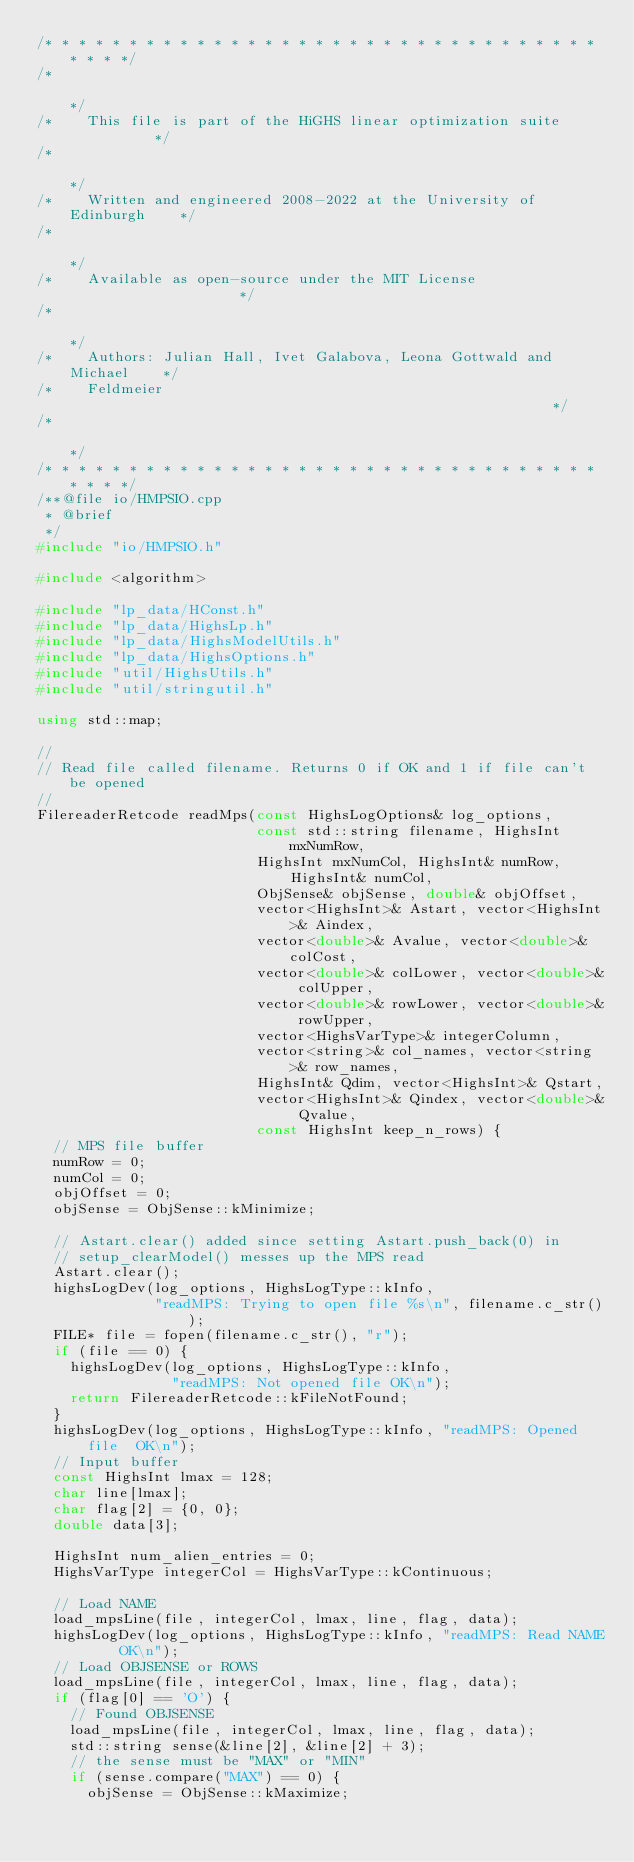<code> <loc_0><loc_0><loc_500><loc_500><_C++_>/* * * * * * * * * * * * * * * * * * * * * * * * * * * * * * * * * * * * */
/*                                                                       */
/*    This file is part of the HiGHS linear optimization suite           */
/*                                                                       */
/*    Written and engineered 2008-2022 at the University of Edinburgh    */
/*                                                                       */
/*    Available as open-source under the MIT License                     */
/*                                                                       */
/*    Authors: Julian Hall, Ivet Galabova, Leona Gottwald and Michael    */
/*    Feldmeier                                                          */
/*                                                                       */
/* * * * * * * * * * * * * * * * * * * * * * * * * * * * * * * * * * * * */
/**@file io/HMPSIO.cpp
 * @brief
 */
#include "io/HMPSIO.h"

#include <algorithm>

#include "lp_data/HConst.h"
#include "lp_data/HighsLp.h"
#include "lp_data/HighsModelUtils.h"
#include "lp_data/HighsOptions.h"
#include "util/HighsUtils.h"
#include "util/stringutil.h"

using std::map;

//
// Read file called filename. Returns 0 if OK and 1 if file can't be opened
//
FilereaderRetcode readMps(const HighsLogOptions& log_options,
                          const std::string filename, HighsInt mxNumRow,
                          HighsInt mxNumCol, HighsInt& numRow, HighsInt& numCol,
                          ObjSense& objSense, double& objOffset,
                          vector<HighsInt>& Astart, vector<HighsInt>& Aindex,
                          vector<double>& Avalue, vector<double>& colCost,
                          vector<double>& colLower, vector<double>& colUpper,
                          vector<double>& rowLower, vector<double>& rowUpper,
                          vector<HighsVarType>& integerColumn,
                          vector<string>& col_names, vector<string>& row_names,
                          HighsInt& Qdim, vector<HighsInt>& Qstart,
                          vector<HighsInt>& Qindex, vector<double>& Qvalue,
                          const HighsInt keep_n_rows) {
  // MPS file buffer
  numRow = 0;
  numCol = 0;
  objOffset = 0;
  objSense = ObjSense::kMinimize;

  // Astart.clear() added since setting Astart.push_back(0) in
  // setup_clearModel() messes up the MPS read
  Astart.clear();
  highsLogDev(log_options, HighsLogType::kInfo,
              "readMPS: Trying to open file %s\n", filename.c_str());
  FILE* file = fopen(filename.c_str(), "r");
  if (file == 0) {
    highsLogDev(log_options, HighsLogType::kInfo,
                "readMPS: Not opened file OK\n");
    return FilereaderRetcode::kFileNotFound;
  }
  highsLogDev(log_options, HighsLogType::kInfo, "readMPS: Opened file  OK\n");
  // Input buffer
  const HighsInt lmax = 128;
  char line[lmax];
  char flag[2] = {0, 0};
  double data[3];

  HighsInt num_alien_entries = 0;
  HighsVarType integerCol = HighsVarType::kContinuous;

  // Load NAME
  load_mpsLine(file, integerCol, lmax, line, flag, data);
  highsLogDev(log_options, HighsLogType::kInfo, "readMPS: Read NAME    OK\n");
  // Load OBJSENSE or ROWS
  load_mpsLine(file, integerCol, lmax, line, flag, data);
  if (flag[0] == 'O') {
    // Found OBJSENSE
    load_mpsLine(file, integerCol, lmax, line, flag, data);
    std::string sense(&line[2], &line[2] + 3);
    // the sense must be "MAX" or "MIN"
    if (sense.compare("MAX") == 0) {
      objSense = ObjSense::kMaximize;</code> 